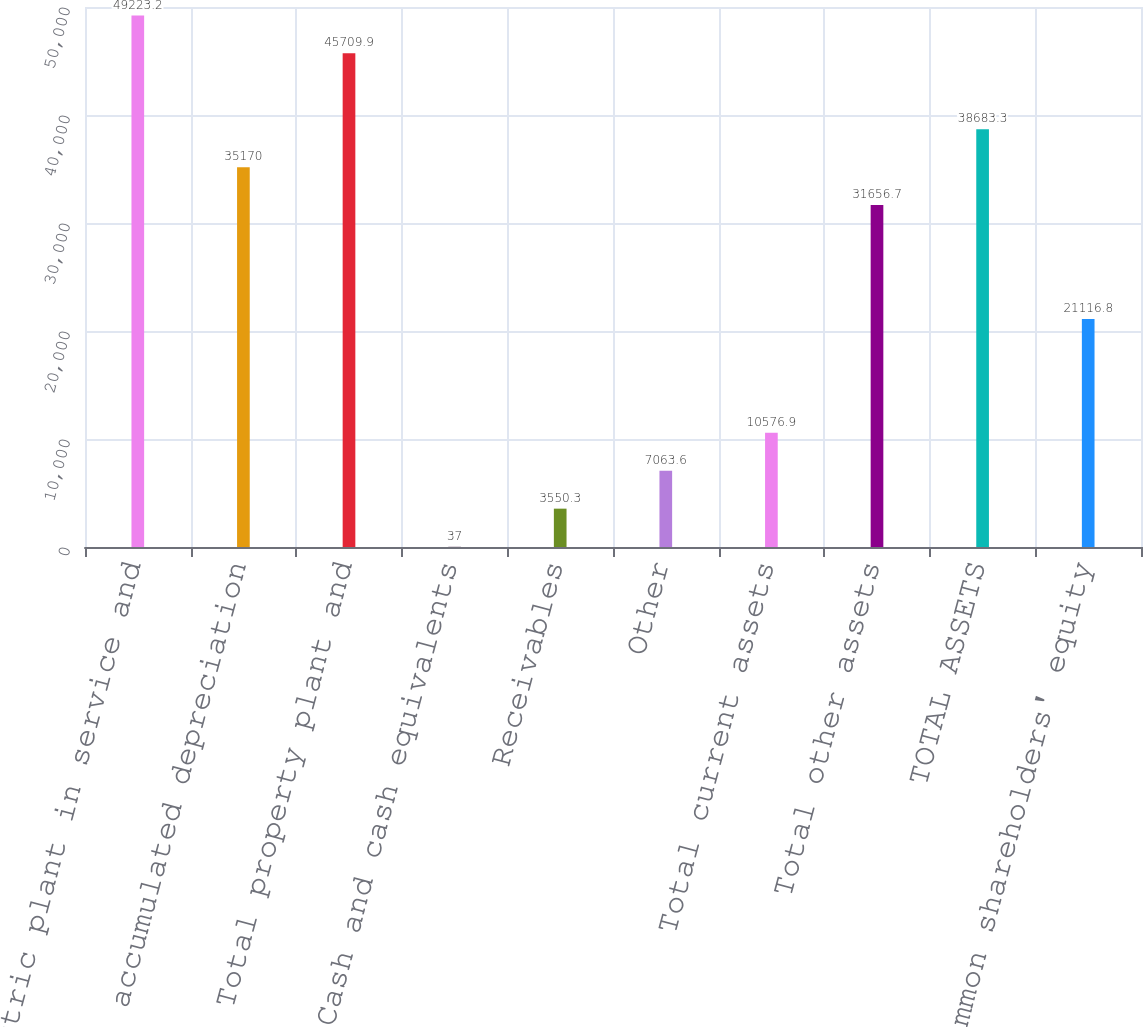Convert chart. <chart><loc_0><loc_0><loc_500><loc_500><bar_chart><fcel>Electric plant in service and<fcel>Less accumulated depreciation<fcel>Total property plant and<fcel>Cash and cash equivalents<fcel>Receivables<fcel>Other<fcel>Total current assets<fcel>Total other assets<fcel>TOTAL ASSETS<fcel>Common shareholders' equity<nl><fcel>49223.2<fcel>35170<fcel>45709.9<fcel>37<fcel>3550.3<fcel>7063.6<fcel>10576.9<fcel>31656.7<fcel>38683.3<fcel>21116.8<nl></chart> 